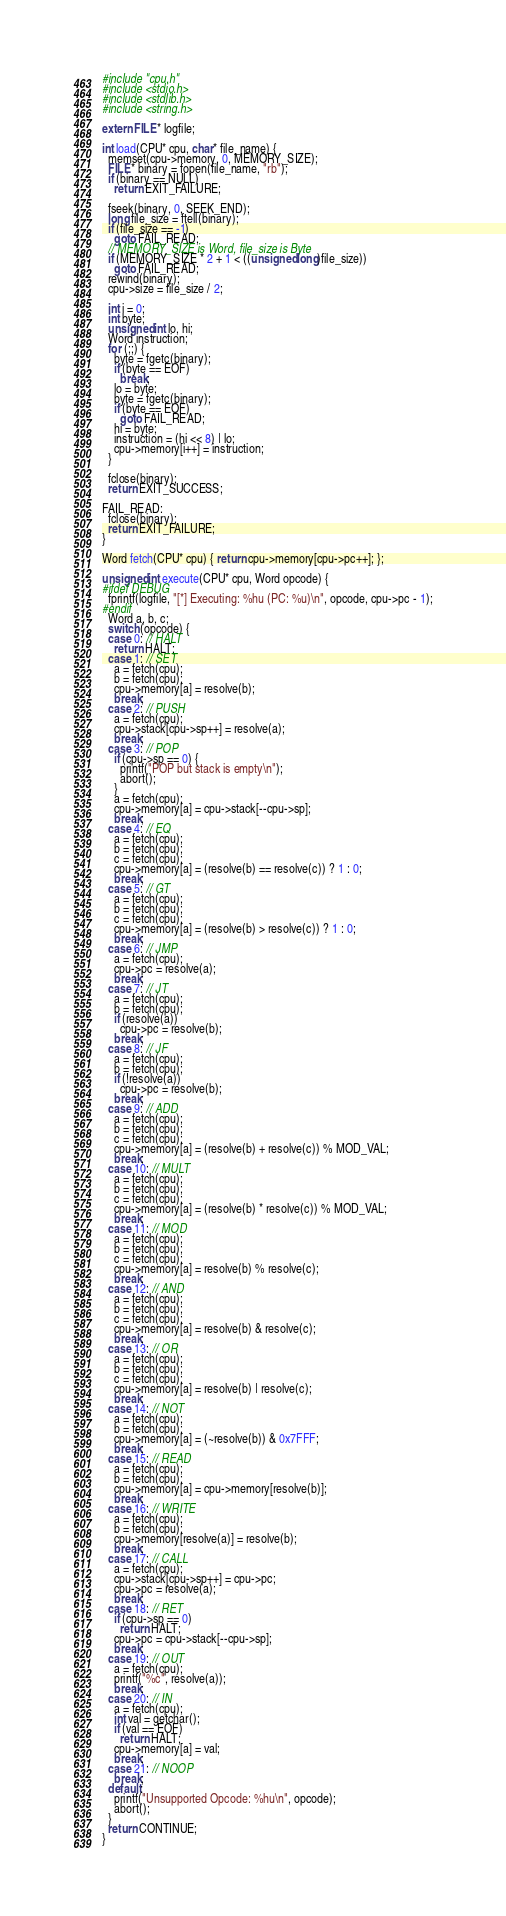<code> <loc_0><loc_0><loc_500><loc_500><_C_>#include "cpu.h"
#include <stdio.h>
#include <stdlib.h>
#include <string.h>

extern FILE* logfile;

int load(CPU* cpu, char* file_name) {
  memset(cpu->memory, 0, MEMORY_SIZE);
  FILE* binary = fopen(file_name, "rb");
  if (binary == NULL)
    return EXIT_FAILURE;

  fseek(binary, 0, SEEK_END);
  long file_size = ftell(binary);
  if (file_size == -1)
    goto FAIL_READ;
  // MEMORY_SIZE is Word, file_size is Byte
  if (MEMORY_SIZE * 2 + 1 < ((unsigned long)file_size))
    goto FAIL_READ;
  rewind(binary);
  cpu->size = file_size / 2;

  int i = 0;
  int byte;
  unsigned int lo, hi;
  Word instruction;
  for (;;) {
    byte = fgetc(binary);
    if (byte == EOF)
      break;
    lo = byte;
    byte = fgetc(binary);
    if (byte == EOF)
      goto FAIL_READ;
    hi = byte;
    instruction = (hi << 8) | lo;
    cpu->memory[i++] = instruction;
  }

  fclose(binary);
  return EXIT_SUCCESS;

FAIL_READ:
  fclose(binary);
  return EXIT_FAILURE;
}

Word fetch(CPU* cpu) { return cpu->memory[cpu->pc++]; };

unsigned int execute(CPU* cpu, Word opcode) {
#ifdef DEBUG
  fprintf(logfile, "[*] Executing: %hu (PC: %u)\n", opcode, cpu->pc - 1);
#endif
  Word a, b, c;
  switch (opcode) {
  case 0: // HALT
    return HALT;
  case 1: // SET
    a = fetch(cpu);
    b = fetch(cpu);
    cpu->memory[a] = resolve(b);
    break;
  case 2: // PUSH
    a = fetch(cpu);
    cpu->stack[cpu->sp++] = resolve(a);
    break;
  case 3: // POP
    if (cpu->sp == 0) {
      printf("POP but stack is empty\n");
      abort();
    }
    a = fetch(cpu);
    cpu->memory[a] = cpu->stack[--cpu->sp];
    break;
  case 4: // EQ
    a = fetch(cpu);
    b = fetch(cpu);
    c = fetch(cpu);
    cpu->memory[a] = (resolve(b) == resolve(c)) ? 1 : 0;
    break;
  case 5: // GT
    a = fetch(cpu);
    b = fetch(cpu);
    c = fetch(cpu);
    cpu->memory[a] = (resolve(b) > resolve(c)) ? 1 : 0;
    break;
  case 6: // JMP
    a = fetch(cpu);
    cpu->pc = resolve(a);
    break;
  case 7: // JT
    a = fetch(cpu);
    b = fetch(cpu);
    if (resolve(a))
      cpu->pc = resolve(b);
    break;
  case 8: // JF
    a = fetch(cpu);
    b = fetch(cpu);
    if (!resolve(a))
      cpu->pc = resolve(b);
    break;
  case 9: // ADD
    a = fetch(cpu);
    b = fetch(cpu);
    c = fetch(cpu);
    cpu->memory[a] = (resolve(b) + resolve(c)) % MOD_VAL;
    break;
  case 10: // MULT
    a = fetch(cpu);
    b = fetch(cpu);
    c = fetch(cpu);
    cpu->memory[a] = (resolve(b) * resolve(c)) % MOD_VAL;
    break;
  case 11: // MOD
    a = fetch(cpu);
    b = fetch(cpu);
    c = fetch(cpu);
    cpu->memory[a] = resolve(b) % resolve(c);
    break;
  case 12: // AND
    a = fetch(cpu);
    b = fetch(cpu);
    c = fetch(cpu);
    cpu->memory[a] = resolve(b) & resolve(c);
    break;
  case 13: // OR
    a = fetch(cpu);
    b = fetch(cpu);
    c = fetch(cpu);
    cpu->memory[a] = resolve(b) | resolve(c);
    break;
  case 14: // NOT
    a = fetch(cpu);
    b = fetch(cpu);
    cpu->memory[a] = (~resolve(b)) & 0x7FFF;
    break;
  case 15: // READ
    a = fetch(cpu);
    b = fetch(cpu);
    cpu->memory[a] = cpu->memory[resolve(b)];
    break;
  case 16: // WRITE
    a = fetch(cpu);
    b = fetch(cpu);
    cpu->memory[resolve(a)] = resolve(b);
    break;
  case 17: // CALL
    a = fetch(cpu);
    cpu->stack[cpu->sp++] = cpu->pc;
    cpu->pc = resolve(a);
    break;
  case 18: // RET
    if (cpu->sp == 0)
      return HALT;
    cpu->pc = cpu->stack[--cpu->sp];
    break;
  case 19: // OUT
    a = fetch(cpu);
    printf("%c", resolve(a));
    break;
  case 20: // IN
    a = fetch(cpu);
    int val = getchar();
    if (val == EOF)
      return HALT;
    cpu->memory[a] = val;
    break;
  case 21: // NOOP
    break;
  default:
    printf("Unsupported Opcode: %hu\n", opcode);
    abort();
  }
  return CONTINUE;
}
</code> 